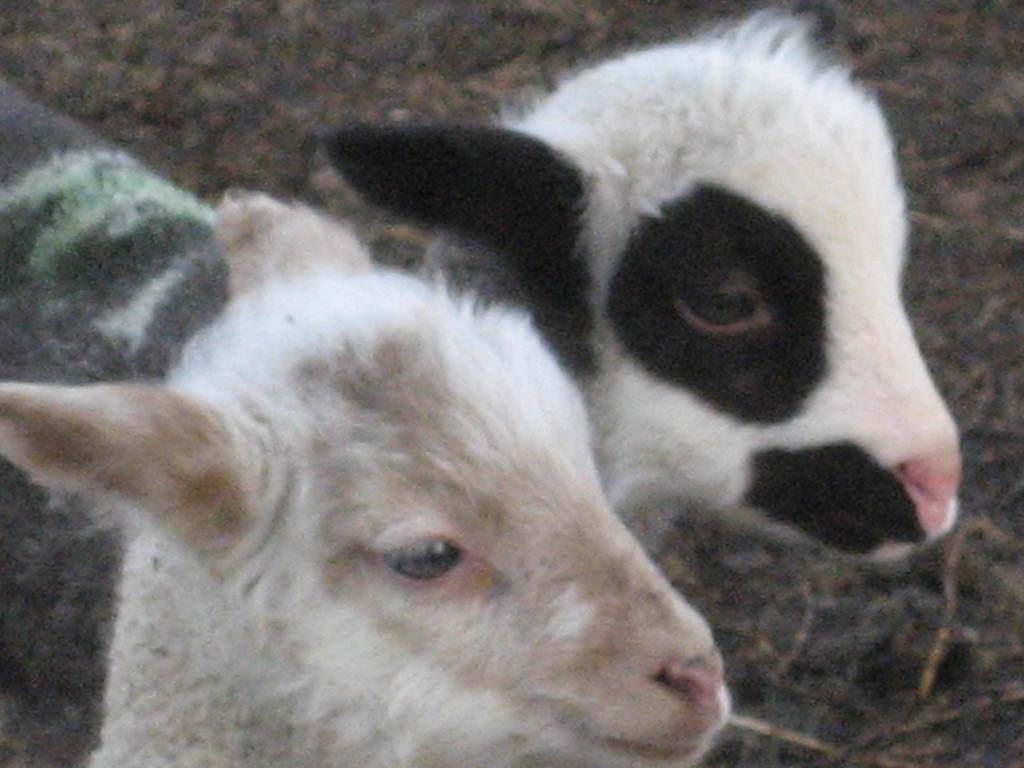What animals are present in the image? There are two sheep in the image. Where are the sheep located in the image? The sheep are on the ground. What type of car can be seen driving past the sheep in the image? There is no car present in the image; it only features two sheep on the ground. What type of educational institution can be seen in the background of the image? There is no educational institution present in the image; it only features two sheep on the ground. 